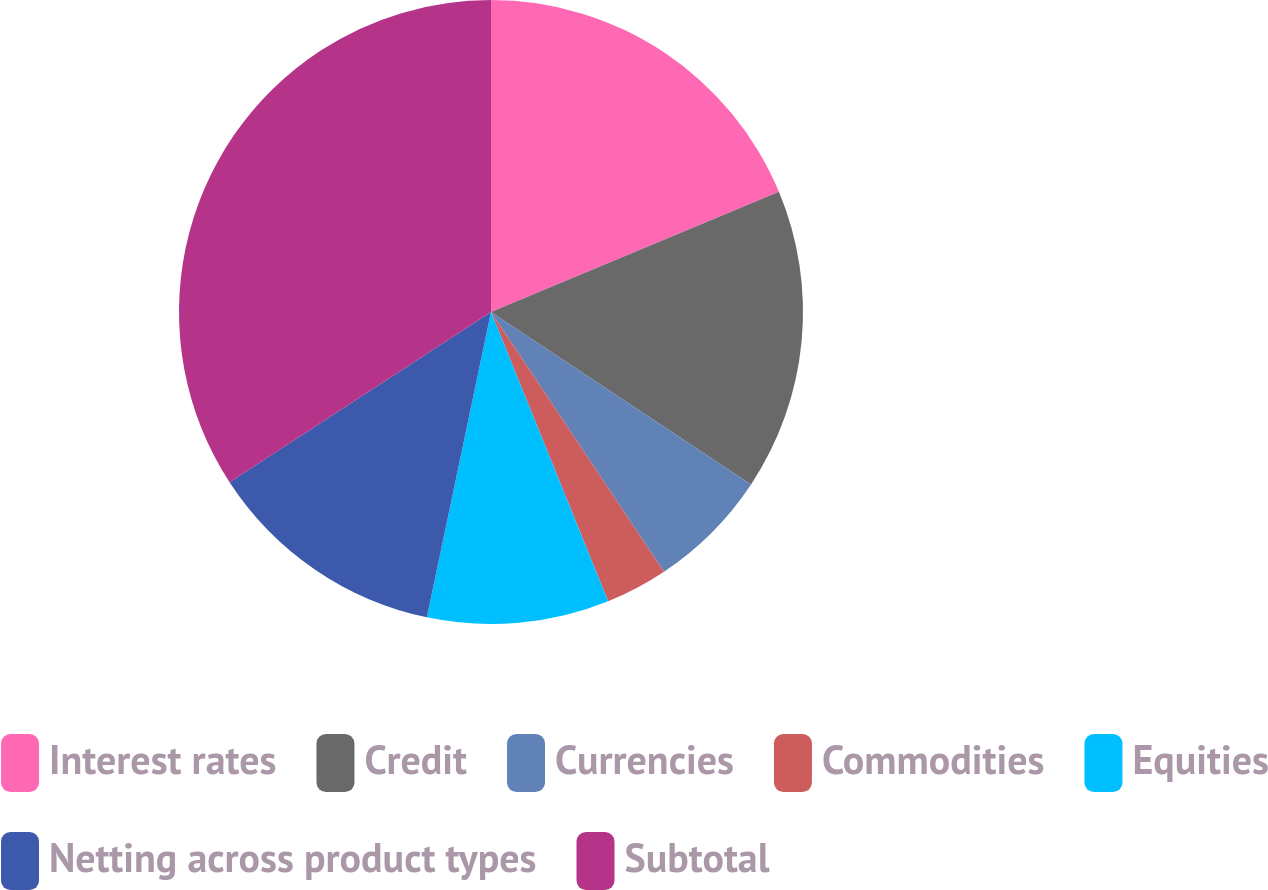<chart> <loc_0><loc_0><loc_500><loc_500><pie_chart><fcel>Interest rates<fcel>Credit<fcel>Currencies<fcel>Commodities<fcel>Equities<fcel>Netting across product types<fcel>Subtotal<nl><fcel>18.71%<fcel>15.61%<fcel>6.33%<fcel>3.23%<fcel>9.42%<fcel>12.52%<fcel>34.19%<nl></chart> 